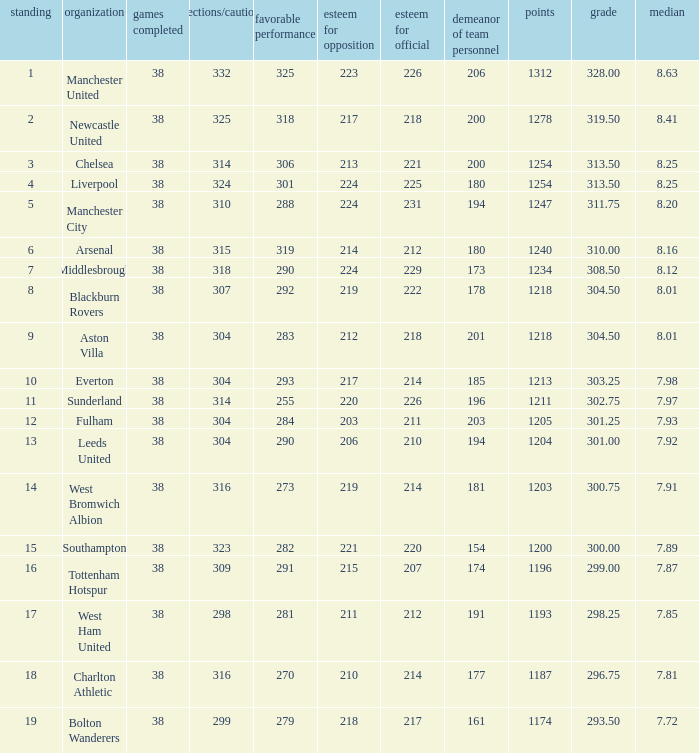Name the most red/yellow cards for positive play being 255 314.0. 